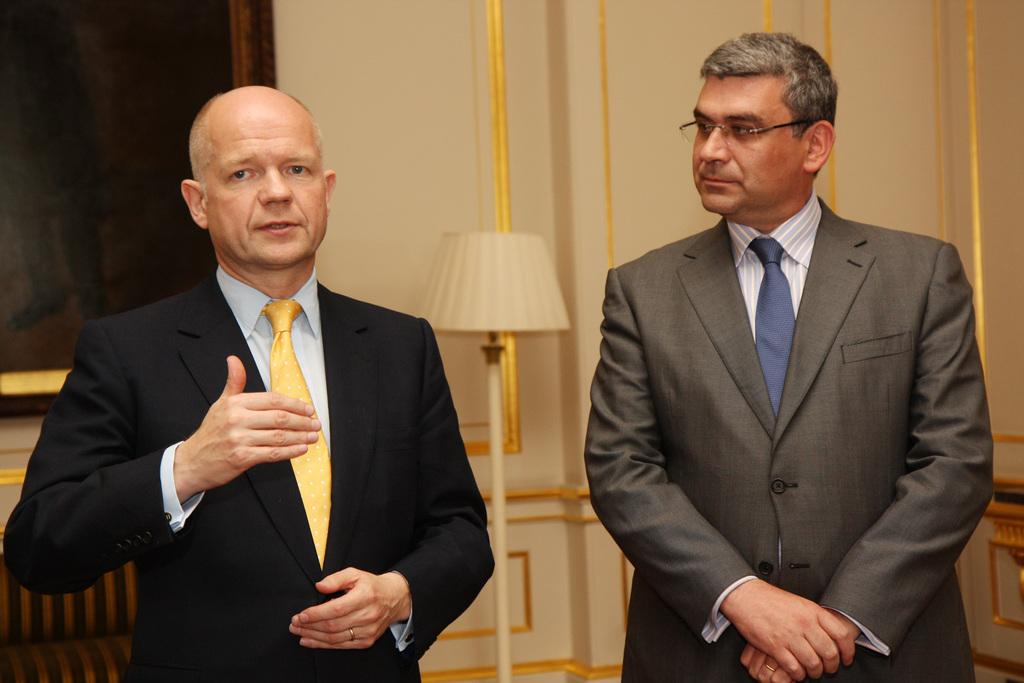How many people are in the image? There are two people standing in the image. Can you describe the appearance of one of the individuals? The person on the right is wearing glasses (specs). What can be seen in the background of the image? There is a standing lamp and a wall in the background of the image. Is there any decoration or object on the wall? Yes, there is a photo frame on the wall in the background of the image. What type of appliance is being used by the person on the left in the image? There is no appliance visible in the image; both individuals are standing without any objects in their hands. 